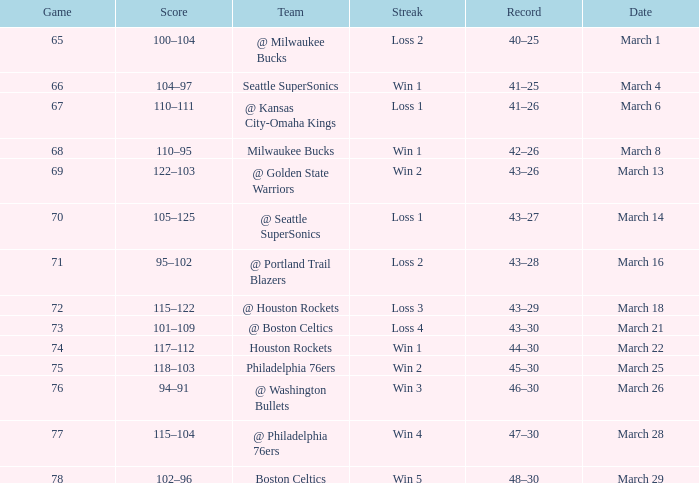Parse the full table. {'header': ['Game', 'Score', 'Team', 'Streak', 'Record', 'Date'], 'rows': [['65', '100–104', '@ Milwaukee Bucks', 'Loss 2', '40–25', 'March 1'], ['66', '104–97', 'Seattle SuperSonics', 'Win 1', '41–25', 'March 4'], ['67', '110–111', '@ Kansas City-Omaha Kings', 'Loss 1', '41–26', 'March 6'], ['68', '110–95', 'Milwaukee Bucks', 'Win 1', '42–26', 'March 8'], ['69', '122–103', '@ Golden State Warriors', 'Win 2', '43–26', 'March 13'], ['70', '105–125', '@ Seattle SuperSonics', 'Loss 1', '43–27', 'March 14'], ['71', '95–102', '@ Portland Trail Blazers', 'Loss 2', '43–28', 'March 16'], ['72', '115–122', '@ Houston Rockets', 'Loss 3', '43–29', 'March 18'], ['73', '101–109', '@ Boston Celtics', 'Loss 4', '43–30', 'March 21'], ['74', '117–112', 'Houston Rockets', 'Win 1', '44–30', 'March 22'], ['75', '118–103', 'Philadelphia 76ers', 'Win 2', '45–30', 'March 25'], ['76', '94–91', '@ Washington Bullets', 'Win 3', '46–30', 'March 26'], ['77', '115–104', '@ Philadelphia 76ers', 'Win 4', '47–30', 'March 28'], ['78', '102–96', 'Boston Celtics', 'Win 5', '48–30', 'March 29']]} What is Team, when Game is 73? @ Boston Celtics. 